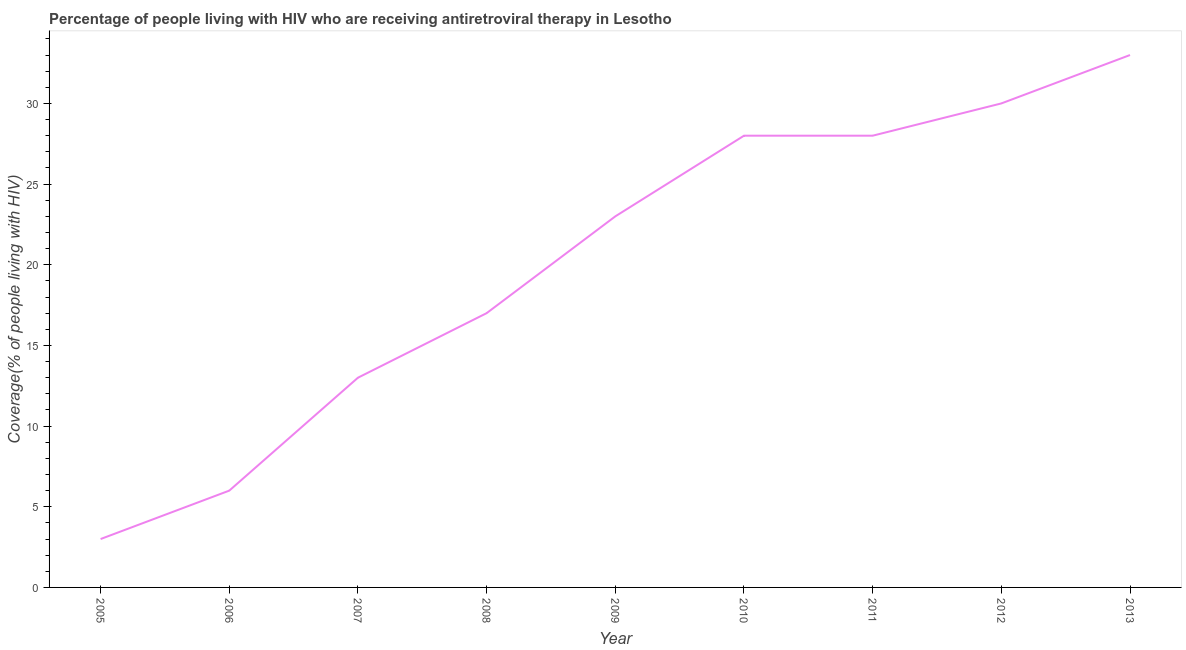What is the antiretroviral therapy coverage in 2009?
Provide a short and direct response. 23. Across all years, what is the maximum antiretroviral therapy coverage?
Give a very brief answer. 33. Across all years, what is the minimum antiretroviral therapy coverage?
Your answer should be very brief. 3. In which year was the antiretroviral therapy coverage minimum?
Make the answer very short. 2005. What is the sum of the antiretroviral therapy coverage?
Give a very brief answer. 181. What is the difference between the antiretroviral therapy coverage in 2006 and 2013?
Ensure brevity in your answer.  -27. What is the average antiretroviral therapy coverage per year?
Offer a terse response. 20.11. What is the median antiretroviral therapy coverage?
Make the answer very short. 23. In how many years, is the antiretroviral therapy coverage greater than 28 %?
Ensure brevity in your answer.  2. What is the ratio of the antiretroviral therapy coverage in 2012 to that in 2013?
Ensure brevity in your answer.  0.91. What is the difference between the highest and the second highest antiretroviral therapy coverage?
Your response must be concise. 3. What is the difference between the highest and the lowest antiretroviral therapy coverage?
Your response must be concise. 30. What is the difference between two consecutive major ticks on the Y-axis?
Keep it short and to the point. 5. Are the values on the major ticks of Y-axis written in scientific E-notation?
Make the answer very short. No. Does the graph contain any zero values?
Provide a succinct answer. No. Does the graph contain grids?
Offer a terse response. No. What is the title of the graph?
Ensure brevity in your answer.  Percentage of people living with HIV who are receiving antiretroviral therapy in Lesotho. What is the label or title of the Y-axis?
Your response must be concise. Coverage(% of people living with HIV). What is the Coverage(% of people living with HIV) in 2005?
Keep it short and to the point. 3. What is the Coverage(% of people living with HIV) of 2006?
Your answer should be compact. 6. What is the Coverage(% of people living with HIV) of 2008?
Your answer should be very brief. 17. What is the Coverage(% of people living with HIV) of 2010?
Make the answer very short. 28. What is the Coverage(% of people living with HIV) of 2011?
Keep it short and to the point. 28. What is the Coverage(% of people living with HIV) of 2013?
Keep it short and to the point. 33. What is the difference between the Coverage(% of people living with HIV) in 2005 and 2006?
Offer a terse response. -3. What is the difference between the Coverage(% of people living with HIV) in 2005 and 2007?
Your answer should be compact. -10. What is the difference between the Coverage(% of people living with HIV) in 2005 and 2008?
Make the answer very short. -14. What is the difference between the Coverage(% of people living with HIV) in 2005 and 2009?
Give a very brief answer. -20. What is the difference between the Coverage(% of people living with HIV) in 2005 and 2011?
Your answer should be very brief. -25. What is the difference between the Coverage(% of people living with HIV) in 2006 and 2007?
Your answer should be very brief. -7. What is the difference between the Coverage(% of people living with HIV) in 2006 and 2008?
Provide a short and direct response. -11. What is the difference between the Coverage(% of people living with HIV) in 2006 and 2010?
Your answer should be compact. -22. What is the difference between the Coverage(% of people living with HIV) in 2006 and 2011?
Your answer should be compact. -22. What is the difference between the Coverage(% of people living with HIV) in 2007 and 2011?
Your response must be concise. -15. What is the difference between the Coverage(% of people living with HIV) in 2007 and 2013?
Your answer should be compact. -20. What is the difference between the Coverage(% of people living with HIV) in 2008 and 2010?
Offer a very short reply. -11. What is the difference between the Coverage(% of people living with HIV) in 2008 and 2011?
Keep it short and to the point. -11. What is the difference between the Coverage(% of people living with HIV) in 2008 and 2012?
Provide a succinct answer. -13. What is the difference between the Coverage(% of people living with HIV) in 2008 and 2013?
Make the answer very short. -16. What is the difference between the Coverage(% of people living with HIV) in 2009 and 2010?
Your response must be concise. -5. What is the difference between the Coverage(% of people living with HIV) in 2009 and 2013?
Keep it short and to the point. -10. What is the difference between the Coverage(% of people living with HIV) in 2010 and 2011?
Ensure brevity in your answer.  0. What is the difference between the Coverage(% of people living with HIV) in 2010 and 2013?
Provide a succinct answer. -5. What is the difference between the Coverage(% of people living with HIV) in 2011 and 2012?
Provide a succinct answer. -2. What is the difference between the Coverage(% of people living with HIV) in 2011 and 2013?
Offer a terse response. -5. What is the difference between the Coverage(% of people living with HIV) in 2012 and 2013?
Give a very brief answer. -3. What is the ratio of the Coverage(% of people living with HIV) in 2005 to that in 2007?
Ensure brevity in your answer.  0.23. What is the ratio of the Coverage(% of people living with HIV) in 2005 to that in 2008?
Give a very brief answer. 0.18. What is the ratio of the Coverage(% of people living with HIV) in 2005 to that in 2009?
Your response must be concise. 0.13. What is the ratio of the Coverage(% of people living with HIV) in 2005 to that in 2010?
Your answer should be compact. 0.11. What is the ratio of the Coverage(% of people living with HIV) in 2005 to that in 2011?
Ensure brevity in your answer.  0.11. What is the ratio of the Coverage(% of people living with HIV) in 2005 to that in 2012?
Give a very brief answer. 0.1. What is the ratio of the Coverage(% of people living with HIV) in 2005 to that in 2013?
Provide a short and direct response. 0.09. What is the ratio of the Coverage(% of people living with HIV) in 2006 to that in 2007?
Provide a short and direct response. 0.46. What is the ratio of the Coverage(% of people living with HIV) in 2006 to that in 2008?
Ensure brevity in your answer.  0.35. What is the ratio of the Coverage(% of people living with HIV) in 2006 to that in 2009?
Your response must be concise. 0.26. What is the ratio of the Coverage(% of people living with HIV) in 2006 to that in 2010?
Make the answer very short. 0.21. What is the ratio of the Coverage(% of people living with HIV) in 2006 to that in 2011?
Provide a succinct answer. 0.21. What is the ratio of the Coverage(% of people living with HIV) in 2006 to that in 2012?
Give a very brief answer. 0.2. What is the ratio of the Coverage(% of people living with HIV) in 2006 to that in 2013?
Provide a succinct answer. 0.18. What is the ratio of the Coverage(% of people living with HIV) in 2007 to that in 2008?
Offer a very short reply. 0.77. What is the ratio of the Coverage(% of people living with HIV) in 2007 to that in 2009?
Your answer should be very brief. 0.56. What is the ratio of the Coverage(% of people living with HIV) in 2007 to that in 2010?
Your answer should be compact. 0.46. What is the ratio of the Coverage(% of people living with HIV) in 2007 to that in 2011?
Your answer should be very brief. 0.46. What is the ratio of the Coverage(% of people living with HIV) in 2007 to that in 2012?
Provide a short and direct response. 0.43. What is the ratio of the Coverage(% of people living with HIV) in 2007 to that in 2013?
Provide a short and direct response. 0.39. What is the ratio of the Coverage(% of people living with HIV) in 2008 to that in 2009?
Offer a terse response. 0.74. What is the ratio of the Coverage(% of people living with HIV) in 2008 to that in 2010?
Provide a short and direct response. 0.61. What is the ratio of the Coverage(% of people living with HIV) in 2008 to that in 2011?
Your response must be concise. 0.61. What is the ratio of the Coverage(% of people living with HIV) in 2008 to that in 2012?
Offer a very short reply. 0.57. What is the ratio of the Coverage(% of people living with HIV) in 2008 to that in 2013?
Ensure brevity in your answer.  0.52. What is the ratio of the Coverage(% of people living with HIV) in 2009 to that in 2010?
Make the answer very short. 0.82. What is the ratio of the Coverage(% of people living with HIV) in 2009 to that in 2011?
Provide a short and direct response. 0.82. What is the ratio of the Coverage(% of people living with HIV) in 2009 to that in 2012?
Your response must be concise. 0.77. What is the ratio of the Coverage(% of people living with HIV) in 2009 to that in 2013?
Your answer should be very brief. 0.7. What is the ratio of the Coverage(% of people living with HIV) in 2010 to that in 2011?
Provide a short and direct response. 1. What is the ratio of the Coverage(% of people living with HIV) in 2010 to that in 2012?
Give a very brief answer. 0.93. What is the ratio of the Coverage(% of people living with HIV) in 2010 to that in 2013?
Make the answer very short. 0.85. What is the ratio of the Coverage(% of people living with HIV) in 2011 to that in 2012?
Offer a very short reply. 0.93. What is the ratio of the Coverage(% of people living with HIV) in 2011 to that in 2013?
Provide a succinct answer. 0.85. What is the ratio of the Coverage(% of people living with HIV) in 2012 to that in 2013?
Ensure brevity in your answer.  0.91. 